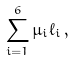Convert formula to latex. <formula><loc_0><loc_0><loc_500><loc_500>\sum _ { i = 1 } ^ { 6 } \mu _ { i } \ell _ { i } \, ,</formula> 